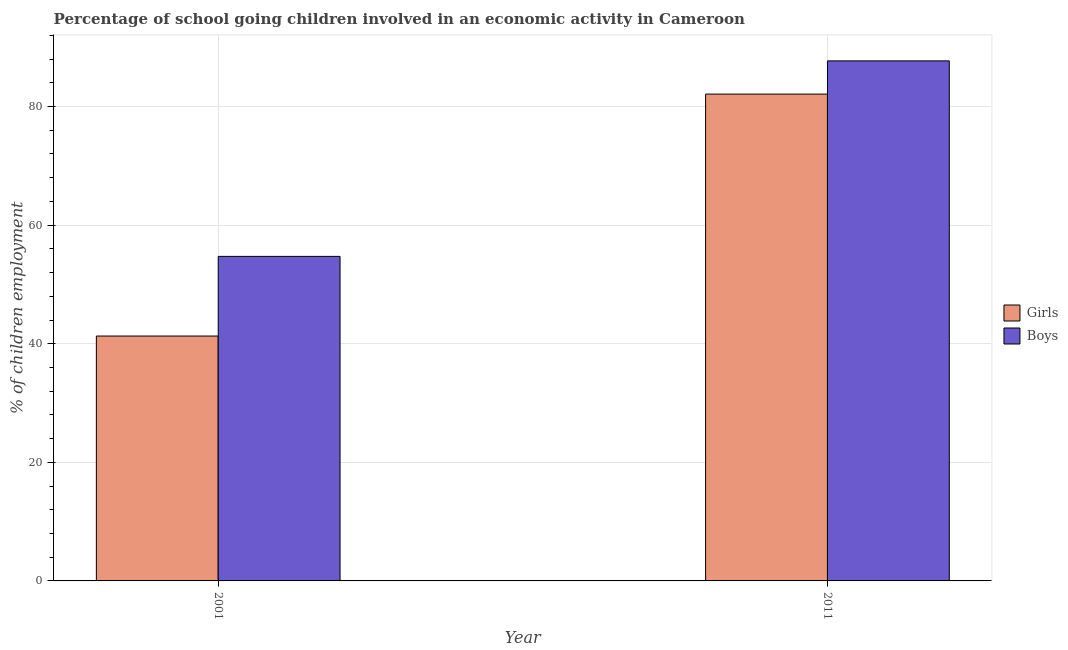How many groups of bars are there?
Keep it short and to the point. 2. What is the label of the 1st group of bars from the left?
Offer a terse response. 2001. In how many cases, is the number of bars for a given year not equal to the number of legend labels?
Your response must be concise. 0. What is the percentage of school going boys in 2011?
Provide a short and direct response. 87.7. Across all years, what is the maximum percentage of school going boys?
Your answer should be very brief. 87.7. Across all years, what is the minimum percentage of school going girls?
Your answer should be very brief. 41.3. In which year was the percentage of school going girls minimum?
Keep it short and to the point. 2001. What is the total percentage of school going boys in the graph?
Your response must be concise. 142.43. What is the difference between the percentage of school going girls in 2001 and that in 2011?
Your response must be concise. -40.8. What is the difference between the percentage of school going girls in 2011 and the percentage of school going boys in 2001?
Offer a terse response. 40.8. What is the average percentage of school going boys per year?
Ensure brevity in your answer.  71.21. In how many years, is the percentage of school going girls greater than 72 %?
Provide a short and direct response. 1. What is the ratio of the percentage of school going boys in 2001 to that in 2011?
Offer a terse response. 0.62. Is the percentage of school going girls in 2001 less than that in 2011?
Give a very brief answer. Yes. What does the 1st bar from the left in 2011 represents?
Offer a terse response. Girls. What does the 2nd bar from the right in 2011 represents?
Make the answer very short. Girls. Are all the bars in the graph horizontal?
Offer a terse response. No. How many years are there in the graph?
Offer a very short reply. 2. Does the graph contain any zero values?
Give a very brief answer. No. Where does the legend appear in the graph?
Your answer should be compact. Center right. How many legend labels are there?
Your answer should be compact. 2. What is the title of the graph?
Your answer should be compact. Percentage of school going children involved in an economic activity in Cameroon. What is the label or title of the Y-axis?
Your response must be concise. % of children employment. What is the % of children employment of Girls in 2001?
Your answer should be compact. 41.3. What is the % of children employment in Boys in 2001?
Give a very brief answer. 54.73. What is the % of children employment in Girls in 2011?
Provide a short and direct response. 82.1. What is the % of children employment in Boys in 2011?
Offer a terse response. 87.7. Across all years, what is the maximum % of children employment of Girls?
Keep it short and to the point. 82.1. Across all years, what is the maximum % of children employment in Boys?
Your answer should be compact. 87.7. Across all years, what is the minimum % of children employment of Girls?
Ensure brevity in your answer.  41.3. Across all years, what is the minimum % of children employment of Boys?
Ensure brevity in your answer.  54.73. What is the total % of children employment of Girls in the graph?
Provide a succinct answer. 123.4. What is the total % of children employment in Boys in the graph?
Give a very brief answer. 142.43. What is the difference between the % of children employment of Girls in 2001 and that in 2011?
Your answer should be compact. -40.8. What is the difference between the % of children employment in Boys in 2001 and that in 2011?
Give a very brief answer. -32.97. What is the difference between the % of children employment in Girls in 2001 and the % of children employment in Boys in 2011?
Make the answer very short. -46.4. What is the average % of children employment of Girls per year?
Your answer should be very brief. 61.7. What is the average % of children employment in Boys per year?
Keep it short and to the point. 71.21. In the year 2001, what is the difference between the % of children employment in Girls and % of children employment in Boys?
Give a very brief answer. -13.43. What is the ratio of the % of children employment in Girls in 2001 to that in 2011?
Give a very brief answer. 0.5. What is the ratio of the % of children employment of Boys in 2001 to that in 2011?
Make the answer very short. 0.62. What is the difference between the highest and the second highest % of children employment in Girls?
Offer a terse response. 40.8. What is the difference between the highest and the second highest % of children employment of Boys?
Ensure brevity in your answer.  32.97. What is the difference between the highest and the lowest % of children employment of Girls?
Offer a terse response. 40.8. What is the difference between the highest and the lowest % of children employment of Boys?
Provide a succinct answer. 32.97. 